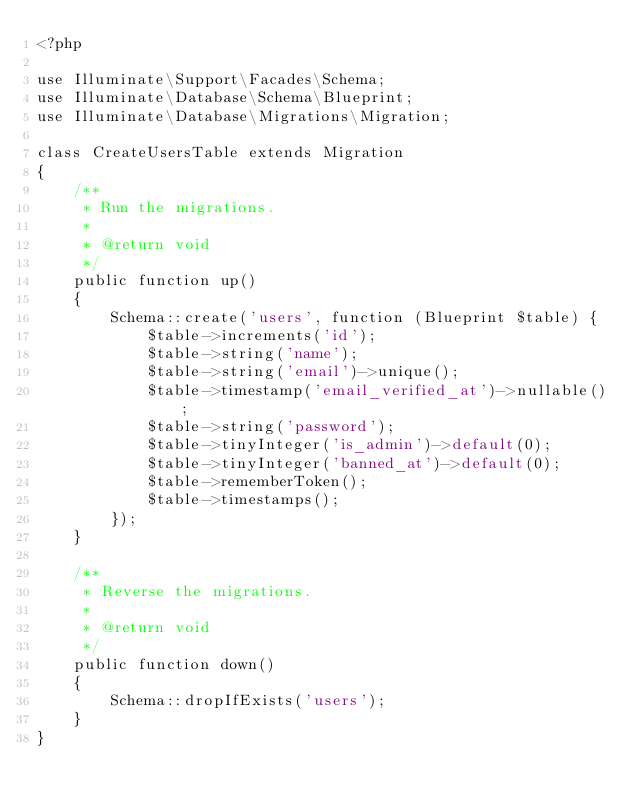<code> <loc_0><loc_0><loc_500><loc_500><_PHP_><?php

use Illuminate\Support\Facades\Schema;
use Illuminate\Database\Schema\Blueprint;
use Illuminate\Database\Migrations\Migration;

class CreateUsersTable extends Migration
{
    /**
     * Run the migrations.
     *
     * @return void
     */
    public function up()
    {
        Schema::create('users', function (Blueprint $table) {
            $table->increments('id');
            $table->string('name');
            $table->string('email')->unique();
            $table->timestamp('email_verified_at')->nullable();
            $table->string('password');
            $table->tinyInteger('is_admin')->default(0);
            $table->tinyInteger('banned_at')->default(0);
            $table->rememberToken();
            $table->timestamps();
        });
    }

    /**
     * Reverse the migrations.
     *
     * @return void
     */
    public function down()
    {
        Schema::dropIfExists('users');
    }
}
</code> 